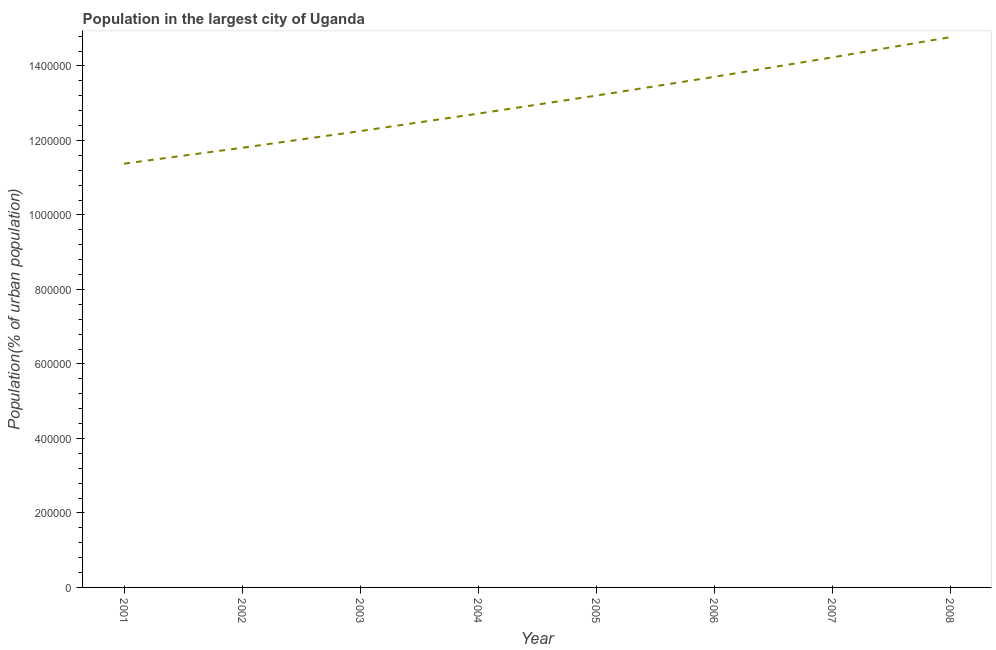What is the population in largest city in 2004?
Offer a very short reply. 1.27e+06. Across all years, what is the maximum population in largest city?
Ensure brevity in your answer.  1.48e+06. Across all years, what is the minimum population in largest city?
Keep it short and to the point. 1.14e+06. In which year was the population in largest city maximum?
Provide a short and direct response. 2008. What is the sum of the population in largest city?
Provide a short and direct response. 1.04e+07. What is the difference between the population in largest city in 2002 and 2003?
Make the answer very short. -4.48e+04. What is the average population in largest city per year?
Offer a terse response. 1.30e+06. What is the median population in largest city?
Provide a succinct answer. 1.30e+06. What is the ratio of the population in largest city in 2004 to that in 2008?
Your response must be concise. 0.86. What is the difference between the highest and the second highest population in largest city?
Give a very brief answer. 5.43e+04. Is the sum of the population in largest city in 2006 and 2008 greater than the maximum population in largest city across all years?
Keep it short and to the point. Yes. What is the difference between the highest and the lowest population in largest city?
Give a very brief answer. 3.40e+05. In how many years, is the population in largest city greater than the average population in largest city taken over all years?
Your answer should be very brief. 4. Does the population in largest city monotonically increase over the years?
Your response must be concise. Yes. How many lines are there?
Keep it short and to the point. 1. How many years are there in the graph?
Your answer should be very brief. 8. What is the difference between two consecutive major ticks on the Y-axis?
Offer a terse response. 2.00e+05. Are the values on the major ticks of Y-axis written in scientific E-notation?
Offer a very short reply. No. What is the title of the graph?
Make the answer very short. Population in the largest city of Uganda. What is the label or title of the Y-axis?
Make the answer very short. Population(% of urban population). What is the Population(% of urban population) in 2001?
Offer a terse response. 1.14e+06. What is the Population(% of urban population) of 2002?
Give a very brief answer. 1.18e+06. What is the Population(% of urban population) in 2003?
Ensure brevity in your answer.  1.23e+06. What is the Population(% of urban population) of 2004?
Give a very brief answer. 1.27e+06. What is the Population(% of urban population) of 2005?
Ensure brevity in your answer.  1.32e+06. What is the Population(% of urban population) of 2006?
Make the answer very short. 1.37e+06. What is the Population(% of urban population) of 2007?
Your answer should be compact. 1.42e+06. What is the Population(% of urban population) of 2008?
Your response must be concise. 1.48e+06. What is the difference between the Population(% of urban population) in 2001 and 2002?
Provide a succinct answer. -4.26e+04. What is the difference between the Population(% of urban population) in 2001 and 2003?
Keep it short and to the point. -8.75e+04. What is the difference between the Population(% of urban population) in 2001 and 2004?
Keep it short and to the point. -1.34e+05. What is the difference between the Population(% of urban population) in 2001 and 2005?
Keep it short and to the point. -1.83e+05. What is the difference between the Population(% of urban population) in 2001 and 2006?
Provide a short and direct response. -2.33e+05. What is the difference between the Population(% of urban population) in 2001 and 2007?
Offer a very short reply. -2.85e+05. What is the difference between the Population(% of urban population) in 2001 and 2008?
Offer a terse response. -3.40e+05. What is the difference between the Population(% of urban population) in 2002 and 2003?
Your answer should be compact. -4.48e+04. What is the difference between the Population(% of urban population) in 2002 and 2004?
Offer a terse response. -9.16e+04. What is the difference between the Population(% of urban population) in 2002 and 2005?
Keep it short and to the point. -1.40e+05. What is the difference between the Population(% of urban population) in 2002 and 2006?
Provide a succinct answer. -1.90e+05. What is the difference between the Population(% of urban population) in 2002 and 2007?
Offer a very short reply. -2.43e+05. What is the difference between the Population(% of urban population) in 2002 and 2008?
Your answer should be very brief. -2.97e+05. What is the difference between the Population(% of urban population) in 2003 and 2004?
Offer a very short reply. -4.68e+04. What is the difference between the Population(% of urban population) in 2003 and 2005?
Provide a short and direct response. -9.52e+04. What is the difference between the Population(% of urban population) in 2003 and 2006?
Your response must be concise. -1.46e+05. What is the difference between the Population(% of urban population) in 2003 and 2007?
Your answer should be very brief. -1.98e+05. What is the difference between the Population(% of urban population) in 2003 and 2008?
Make the answer very short. -2.52e+05. What is the difference between the Population(% of urban population) in 2004 and 2005?
Give a very brief answer. -4.84e+04. What is the difference between the Population(% of urban population) in 2004 and 2006?
Ensure brevity in your answer.  -9.88e+04. What is the difference between the Population(% of urban population) in 2004 and 2007?
Your answer should be very brief. -1.51e+05. What is the difference between the Population(% of urban population) in 2004 and 2008?
Keep it short and to the point. -2.05e+05. What is the difference between the Population(% of urban population) in 2005 and 2006?
Give a very brief answer. -5.04e+04. What is the difference between the Population(% of urban population) in 2005 and 2007?
Offer a very short reply. -1.03e+05. What is the difference between the Population(% of urban population) in 2005 and 2008?
Provide a succinct answer. -1.57e+05. What is the difference between the Population(% of urban population) in 2006 and 2007?
Ensure brevity in your answer.  -5.23e+04. What is the difference between the Population(% of urban population) in 2006 and 2008?
Your response must be concise. -1.07e+05. What is the difference between the Population(% of urban population) in 2007 and 2008?
Offer a terse response. -5.43e+04. What is the ratio of the Population(% of urban population) in 2001 to that in 2002?
Provide a succinct answer. 0.96. What is the ratio of the Population(% of urban population) in 2001 to that in 2003?
Provide a short and direct response. 0.93. What is the ratio of the Population(% of urban population) in 2001 to that in 2004?
Provide a short and direct response. 0.89. What is the ratio of the Population(% of urban population) in 2001 to that in 2005?
Your response must be concise. 0.86. What is the ratio of the Population(% of urban population) in 2001 to that in 2006?
Keep it short and to the point. 0.83. What is the ratio of the Population(% of urban population) in 2001 to that in 2008?
Your answer should be very brief. 0.77. What is the ratio of the Population(% of urban population) in 2002 to that in 2003?
Offer a very short reply. 0.96. What is the ratio of the Population(% of urban population) in 2002 to that in 2004?
Offer a very short reply. 0.93. What is the ratio of the Population(% of urban population) in 2002 to that in 2005?
Offer a very short reply. 0.89. What is the ratio of the Population(% of urban population) in 2002 to that in 2006?
Offer a very short reply. 0.86. What is the ratio of the Population(% of urban population) in 2002 to that in 2007?
Offer a very short reply. 0.83. What is the ratio of the Population(% of urban population) in 2002 to that in 2008?
Provide a succinct answer. 0.8. What is the ratio of the Population(% of urban population) in 2003 to that in 2004?
Your answer should be compact. 0.96. What is the ratio of the Population(% of urban population) in 2003 to that in 2005?
Give a very brief answer. 0.93. What is the ratio of the Population(% of urban population) in 2003 to that in 2006?
Provide a succinct answer. 0.89. What is the ratio of the Population(% of urban population) in 2003 to that in 2007?
Make the answer very short. 0.86. What is the ratio of the Population(% of urban population) in 2003 to that in 2008?
Ensure brevity in your answer.  0.83. What is the ratio of the Population(% of urban population) in 2004 to that in 2005?
Offer a terse response. 0.96. What is the ratio of the Population(% of urban population) in 2004 to that in 2006?
Give a very brief answer. 0.93. What is the ratio of the Population(% of urban population) in 2004 to that in 2007?
Your response must be concise. 0.89. What is the ratio of the Population(% of urban population) in 2004 to that in 2008?
Make the answer very short. 0.86. What is the ratio of the Population(% of urban population) in 2005 to that in 2007?
Your response must be concise. 0.93. What is the ratio of the Population(% of urban population) in 2005 to that in 2008?
Keep it short and to the point. 0.89. What is the ratio of the Population(% of urban population) in 2006 to that in 2007?
Give a very brief answer. 0.96. What is the ratio of the Population(% of urban population) in 2006 to that in 2008?
Your answer should be compact. 0.93. What is the ratio of the Population(% of urban population) in 2007 to that in 2008?
Provide a succinct answer. 0.96. 